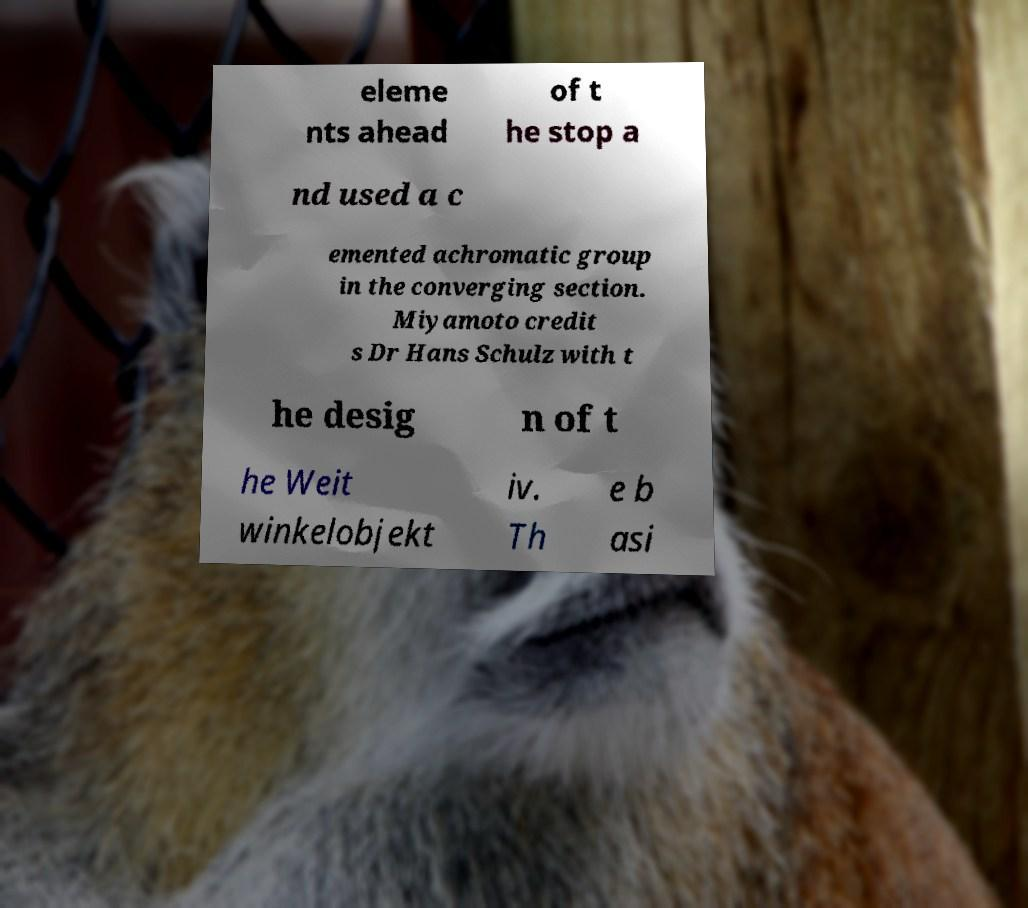For documentation purposes, I need the text within this image transcribed. Could you provide that? eleme nts ahead of t he stop a nd used a c emented achromatic group in the converging section. Miyamoto credit s Dr Hans Schulz with t he desig n of t he Weit winkelobjekt iv. Th e b asi 